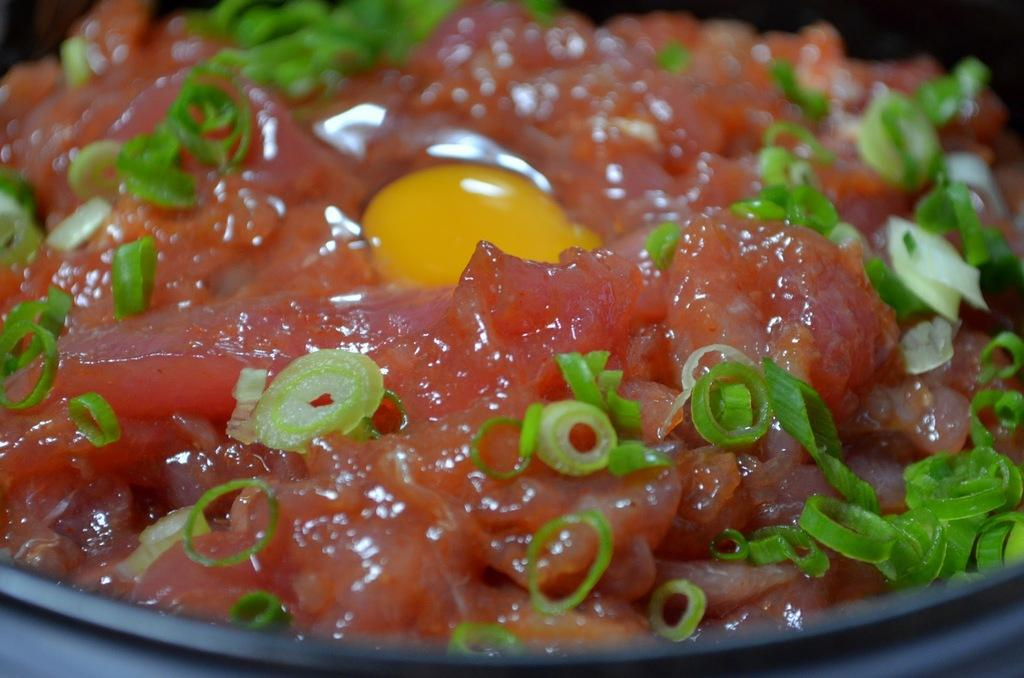What type of food item is present in the image? The image contains a food item. Can you describe any specific details about the food item? Yes, there are green chilies garnished on the food item. What type of seat is visible in the image? There is no seat present in the image; it only contains a food item with green chilies as a garnish. 